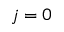<formula> <loc_0><loc_0><loc_500><loc_500>j = 0</formula> 